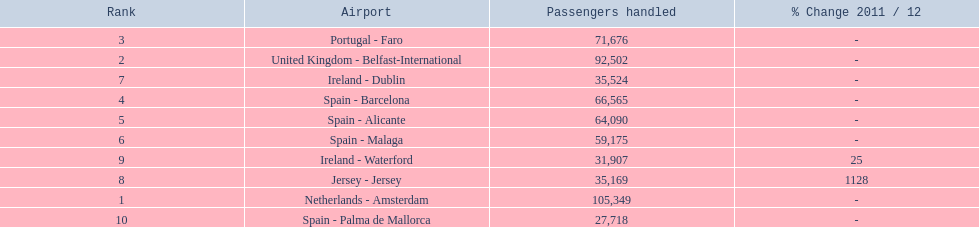What are all of the destinations out of the london southend airport? Netherlands - Amsterdam, United Kingdom - Belfast-International, Portugal - Faro, Spain - Barcelona, Spain - Alicante, Spain - Malaga, Ireland - Dublin, Jersey - Jersey, Ireland - Waterford, Spain - Palma de Mallorca. How many passengers has each destination handled? 105,349, 92,502, 71,676, 66,565, 64,090, 59,175, 35,524, 35,169, 31,907, 27,718. And of those, which airport handled the fewest passengers? Spain - Palma de Mallorca. 